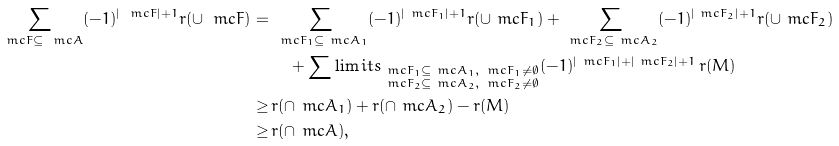Convert formula to latex. <formula><loc_0><loc_0><loc_500><loc_500>\sum _ { \ m c F \subseteq \ m c A } ( - 1 ) ^ { | \ m c F | + 1 } r ( \cup \ m c F ) = \, & \sum _ { \ m c F _ { 1 } \subseteq \ m c A _ { 1 } } ( - 1 ) ^ { | \ m c F _ { 1 } | + 1 } r ( \cup \ m c F _ { 1 } ) + \sum _ { \ m c F _ { 2 } \subseteq \ m c A _ { 2 } } ( - 1 ) ^ { | \ m c F _ { 2 } | + 1 } r ( \cup \ m c F _ { 2 } ) \\ & \quad + \sum \lim i t s _ { \substack { \ m c F _ { 1 } \subseteq \ m c A _ { 1 } , \, \ m c F _ { 1 } \ne \emptyset \\ \ m c F _ { 2 } \subseteq \ m c A _ { 2 } , \, \ m c F _ { 2 } \ne \emptyset } } ( - 1 ) ^ { | \ m c F _ { 1 } | + | \ m c F _ { 2 } | + 1 } \, r ( M ) \\ \geq \, & r ( \cap \ m c A _ { 1 } ) + r ( \cap \ m c A _ { 2 } ) - r ( M ) \\ \geq \, & r ( \cap \ m c A ) ,</formula> 